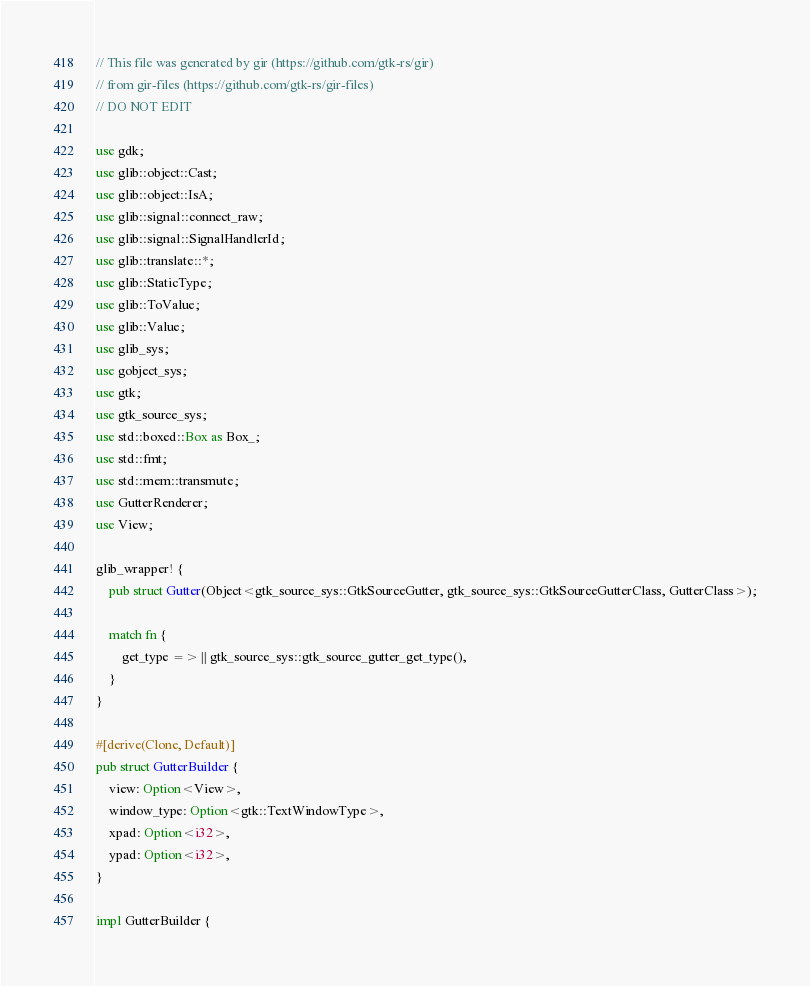Convert code to text. <code><loc_0><loc_0><loc_500><loc_500><_Rust_>// This file was generated by gir (https://github.com/gtk-rs/gir)
// from gir-files (https://github.com/gtk-rs/gir-files)
// DO NOT EDIT

use gdk;
use glib::object::Cast;
use glib::object::IsA;
use glib::signal::connect_raw;
use glib::signal::SignalHandlerId;
use glib::translate::*;
use glib::StaticType;
use glib::ToValue;
use glib::Value;
use glib_sys;
use gobject_sys;
use gtk;
use gtk_source_sys;
use std::boxed::Box as Box_;
use std::fmt;
use std::mem::transmute;
use GutterRenderer;
use View;

glib_wrapper! {
    pub struct Gutter(Object<gtk_source_sys::GtkSourceGutter, gtk_source_sys::GtkSourceGutterClass, GutterClass>);

    match fn {
        get_type => || gtk_source_sys::gtk_source_gutter_get_type(),
    }
}

#[derive(Clone, Default)]
pub struct GutterBuilder {
    view: Option<View>,
    window_type: Option<gtk::TextWindowType>,
    xpad: Option<i32>,
    ypad: Option<i32>,
}

impl GutterBuilder {</code> 